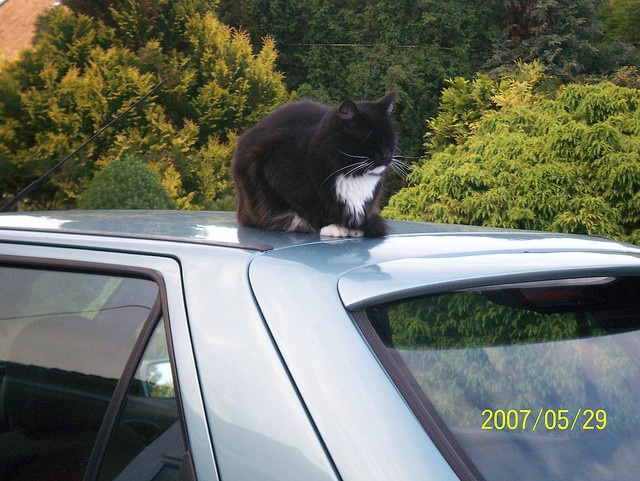Describe the objects in this image and their specific colors. I can see car in white, lightgray, black, darkgray, and gray tones and cat in white, black, gray, and lightgray tones in this image. 